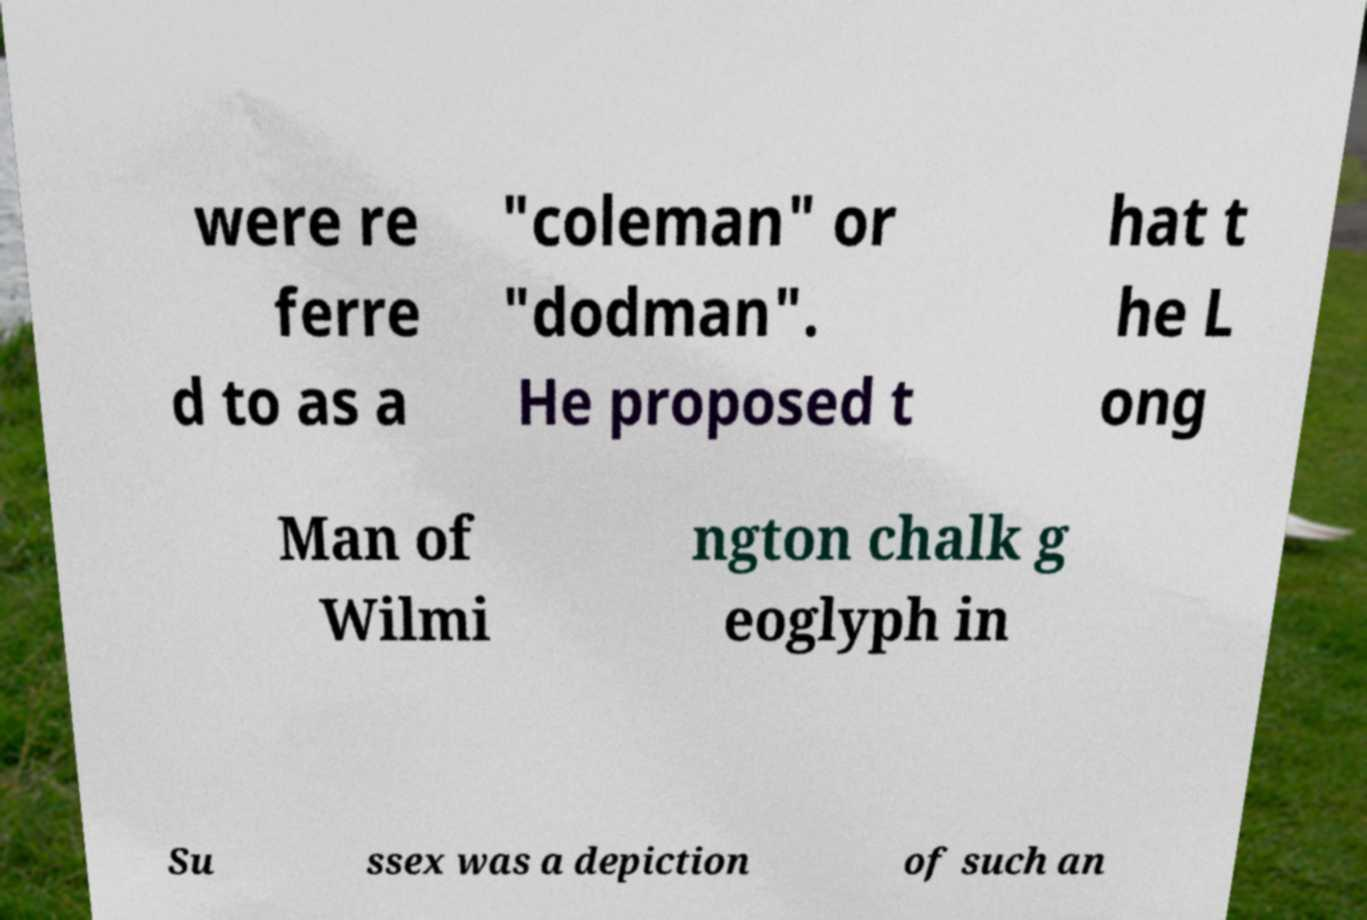Please identify and transcribe the text found in this image. were re ferre d to as a "coleman" or "dodman". He proposed t hat t he L ong Man of Wilmi ngton chalk g eoglyph in Su ssex was a depiction of such an 